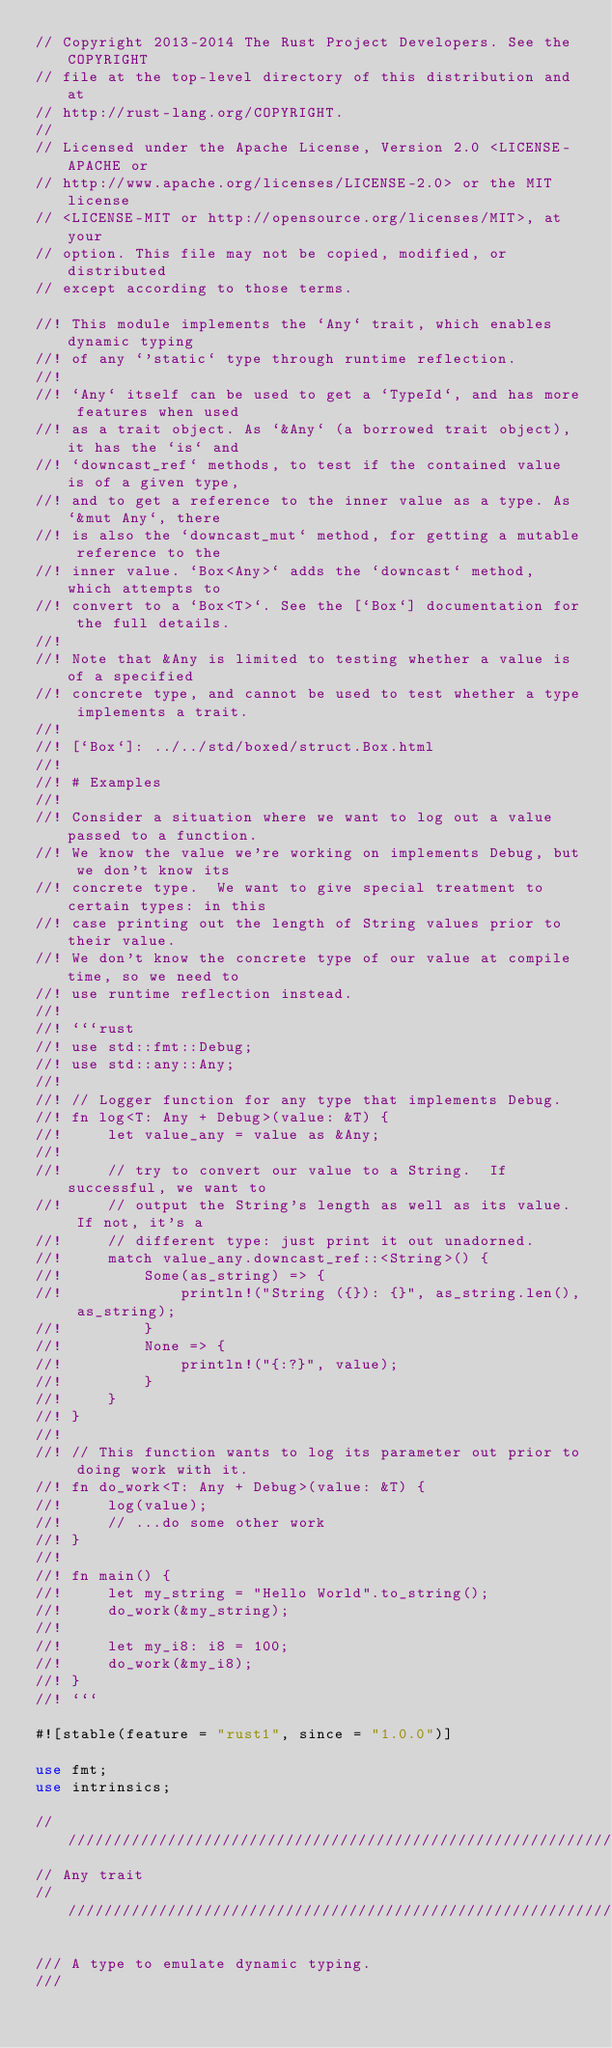Convert code to text. <code><loc_0><loc_0><loc_500><loc_500><_Rust_>// Copyright 2013-2014 The Rust Project Developers. See the COPYRIGHT
// file at the top-level directory of this distribution and at
// http://rust-lang.org/COPYRIGHT.
//
// Licensed under the Apache License, Version 2.0 <LICENSE-APACHE or
// http://www.apache.org/licenses/LICENSE-2.0> or the MIT license
// <LICENSE-MIT or http://opensource.org/licenses/MIT>, at your
// option. This file may not be copied, modified, or distributed
// except according to those terms.

//! This module implements the `Any` trait, which enables dynamic typing
//! of any `'static` type through runtime reflection.
//!
//! `Any` itself can be used to get a `TypeId`, and has more features when used
//! as a trait object. As `&Any` (a borrowed trait object), it has the `is` and
//! `downcast_ref` methods, to test if the contained value is of a given type,
//! and to get a reference to the inner value as a type. As `&mut Any`, there
//! is also the `downcast_mut` method, for getting a mutable reference to the
//! inner value. `Box<Any>` adds the `downcast` method, which attempts to
//! convert to a `Box<T>`. See the [`Box`] documentation for the full details.
//!
//! Note that &Any is limited to testing whether a value is of a specified
//! concrete type, and cannot be used to test whether a type implements a trait.
//!
//! [`Box`]: ../../std/boxed/struct.Box.html
//!
//! # Examples
//!
//! Consider a situation where we want to log out a value passed to a function.
//! We know the value we're working on implements Debug, but we don't know its
//! concrete type.  We want to give special treatment to certain types: in this
//! case printing out the length of String values prior to their value.
//! We don't know the concrete type of our value at compile time, so we need to
//! use runtime reflection instead.
//!
//! ```rust
//! use std::fmt::Debug;
//! use std::any::Any;
//!
//! // Logger function for any type that implements Debug.
//! fn log<T: Any + Debug>(value: &T) {
//!     let value_any = value as &Any;
//!
//!     // try to convert our value to a String.  If successful, we want to
//!     // output the String's length as well as its value.  If not, it's a
//!     // different type: just print it out unadorned.
//!     match value_any.downcast_ref::<String>() {
//!         Some(as_string) => {
//!             println!("String ({}): {}", as_string.len(), as_string);
//!         }
//!         None => {
//!             println!("{:?}", value);
//!         }
//!     }
//! }
//!
//! // This function wants to log its parameter out prior to doing work with it.
//! fn do_work<T: Any + Debug>(value: &T) {
//!     log(value);
//!     // ...do some other work
//! }
//!
//! fn main() {
//!     let my_string = "Hello World".to_string();
//!     do_work(&my_string);
//!
//!     let my_i8: i8 = 100;
//!     do_work(&my_i8);
//! }
//! ```

#![stable(feature = "rust1", since = "1.0.0")]

use fmt;
use intrinsics;

///////////////////////////////////////////////////////////////////////////////
// Any trait
///////////////////////////////////////////////////////////////////////////////

/// A type to emulate dynamic typing.
///</code> 